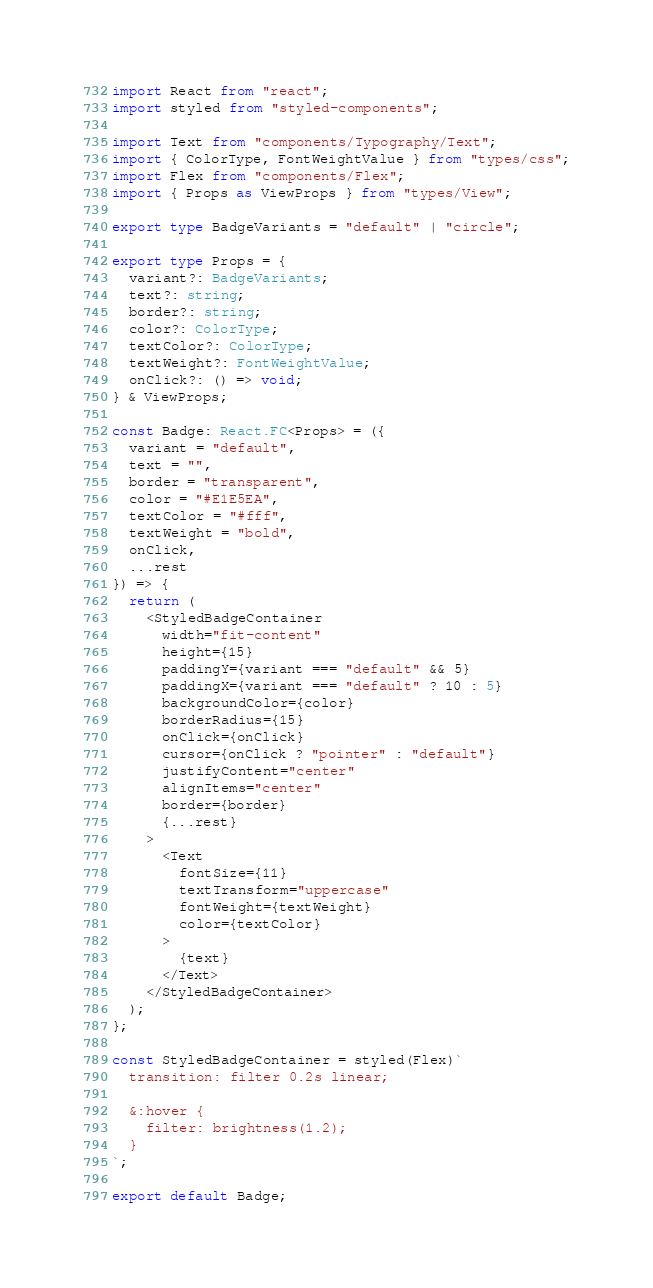Convert code to text. <code><loc_0><loc_0><loc_500><loc_500><_TypeScript_>import React from "react";
import styled from "styled-components";

import Text from "components/Typography/Text";
import { ColorType, FontWeightValue } from "types/css";
import Flex from "components/Flex";
import { Props as ViewProps } from "types/View";

export type BadgeVariants = "default" | "circle";

export type Props = {
  variant?: BadgeVariants;
  text?: string;
  border?: string;
  color?: ColorType;
  textColor?: ColorType;
  textWeight?: FontWeightValue;
  onClick?: () => void;
} & ViewProps;

const Badge: React.FC<Props> = ({
  variant = "default",
  text = "",
  border = "transparent",
  color = "#E1E5EA",
  textColor = "#fff",
  textWeight = "bold",
  onClick,
  ...rest
}) => {
  return (
    <StyledBadgeContainer
      width="fit-content"
      height={15}
      paddingY={variant === "default" && 5}
      paddingX={variant === "default" ? 10 : 5}
      backgroundColor={color}
      borderRadius={15}
      onClick={onClick}
      cursor={onClick ? "pointer" : "default"}
      justifyContent="center"
      alignItems="center"
      border={border}
      {...rest}
    >
      <Text
        fontSize={11}
        textTransform="uppercase"
        fontWeight={textWeight}
        color={textColor}
      >
        {text}
      </Text>
    </StyledBadgeContainer>
  );
};

const StyledBadgeContainer = styled(Flex)`
  transition: filter 0.2s linear;

  &:hover {
    filter: brightness(1.2);
  }
`;

export default Badge;
</code> 